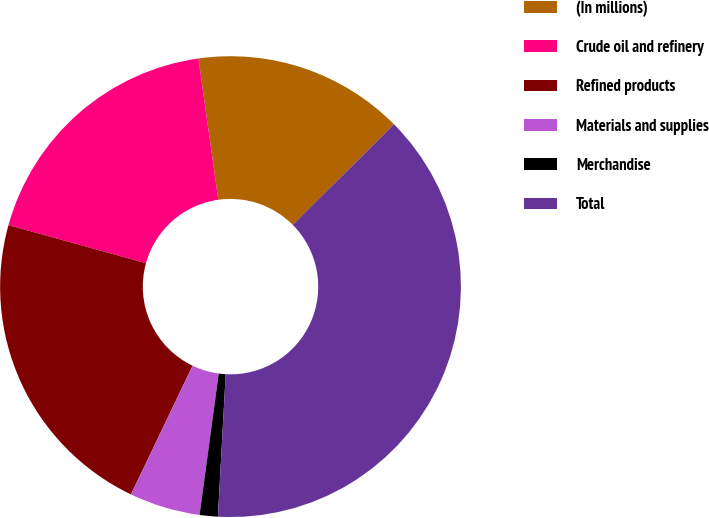<chart> <loc_0><loc_0><loc_500><loc_500><pie_chart><fcel>(In millions)<fcel>Crude oil and refinery<fcel>Refined products<fcel>Materials and supplies<fcel>Merchandise<fcel>Total<nl><fcel>14.78%<fcel>18.48%<fcel>22.19%<fcel>4.97%<fcel>1.27%<fcel>38.32%<nl></chart> 